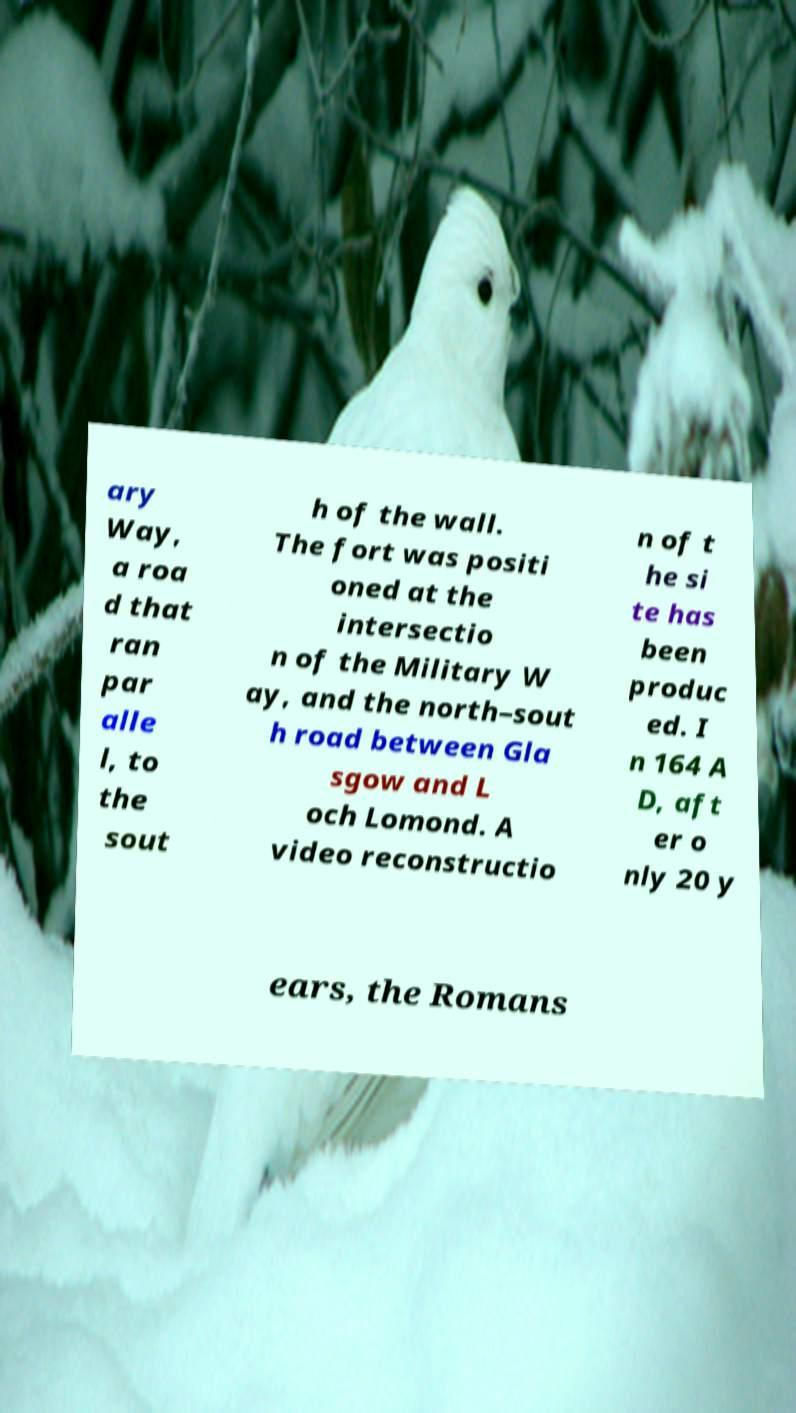Please identify and transcribe the text found in this image. ary Way, a roa d that ran par alle l, to the sout h of the wall. The fort was positi oned at the intersectio n of the Military W ay, and the north–sout h road between Gla sgow and L och Lomond. A video reconstructio n of t he si te has been produc ed. I n 164 A D, aft er o nly 20 y ears, the Romans 